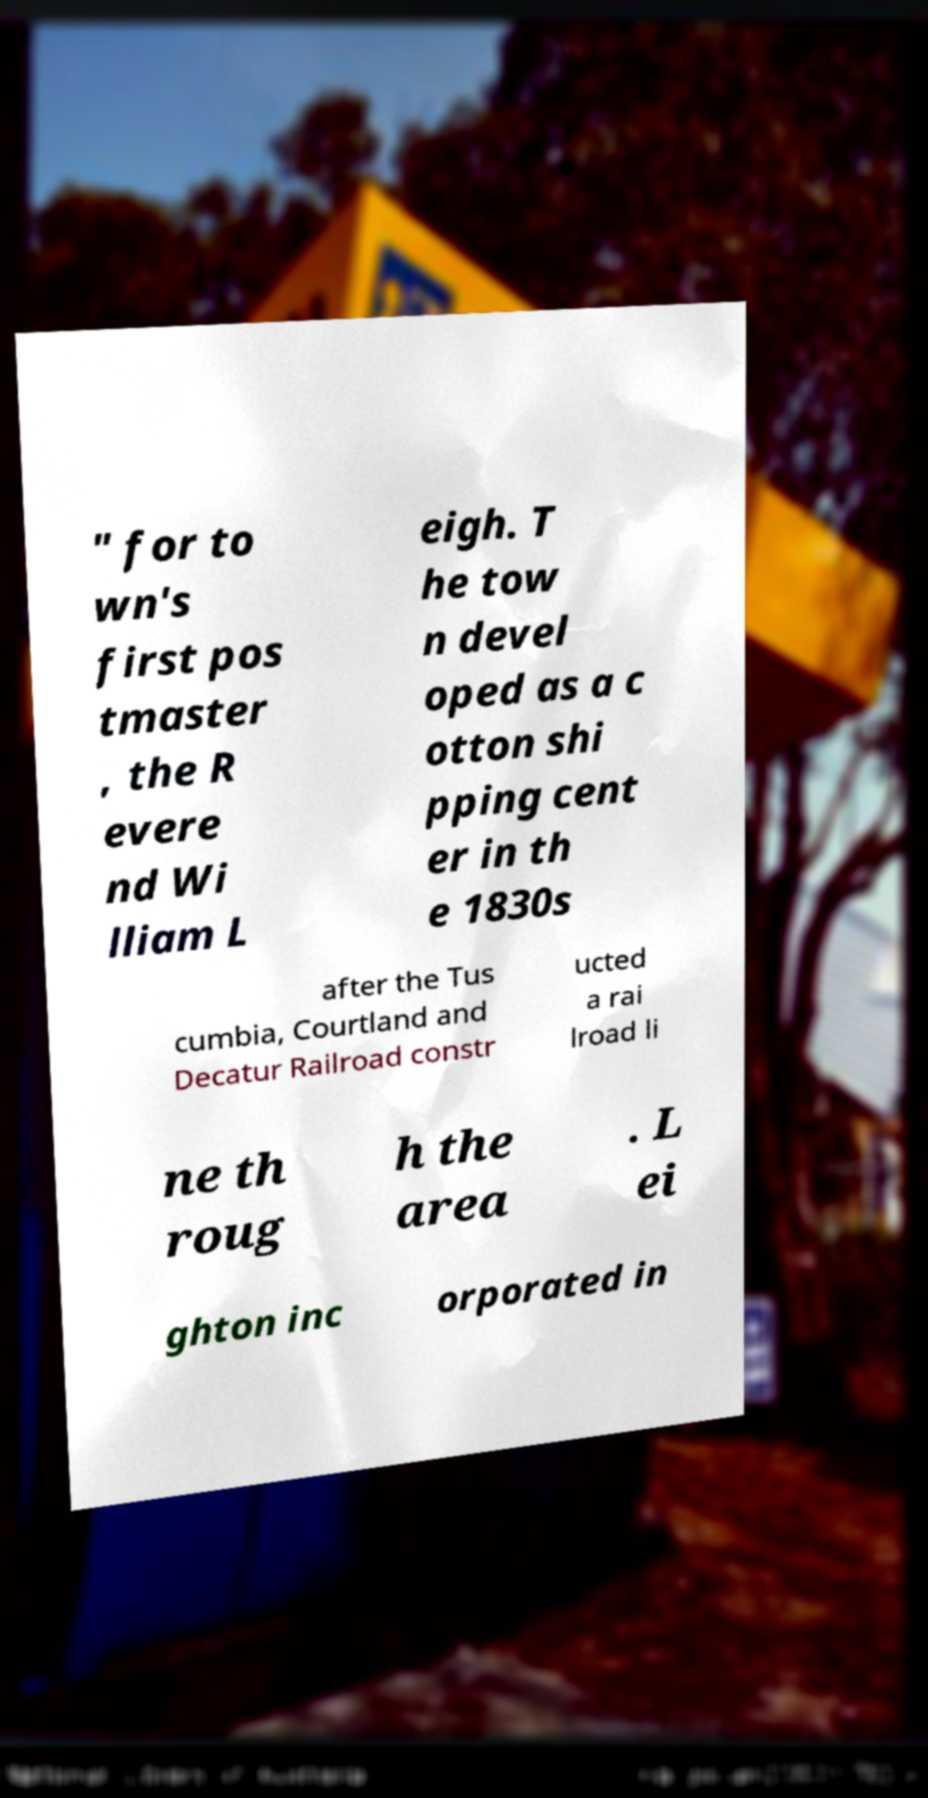Could you assist in decoding the text presented in this image and type it out clearly? " for to wn's first pos tmaster , the R evere nd Wi lliam L eigh. T he tow n devel oped as a c otton shi pping cent er in th e 1830s after the Tus cumbia, Courtland and Decatur Railroad constr ucted a rai lroad li ne th roug h the area . L ei ghton inc orporated in 